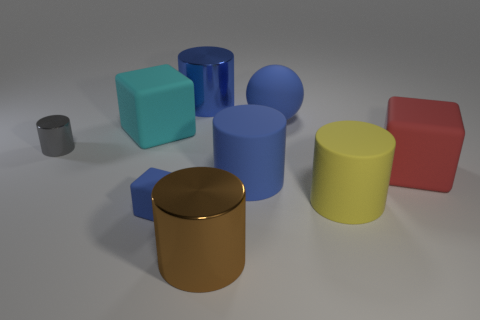Subtract all gray cylinders. How many cylinders are left? 4 Subtract all tiny gray shiny cylinders. How many cylinders are left? 4 Subtract all green cylinders. Subtract all red spheres. How many cylinders are left? 5 Subtract all cubes. How many objects are left? 6 Add 1 small cyan metal balls. How many small cyan metal balls exist? 1 Subtract 1 blue cubes. How many objects are left? 8 Subtract all blue metallic cylinders. Subtract all cyan rubber blocks. How many objects are left? 7 Add 9 small gray metallic objects. How many small gray metallic objects are left? 10 